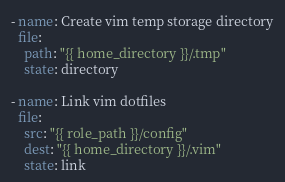<code> <loc_0><loc_0><loc_500><loc_500><_YAML_>- name: Create vim temp storage directory
  file: 
    path: "{{ home_directory }}/.tmp"
    state: directory

- name: Link vim dotfiles
  file:
    src: "{{ role_path }}/config"
    dest: "{{ home_directory }}/.vim"
    state: link
</code> 